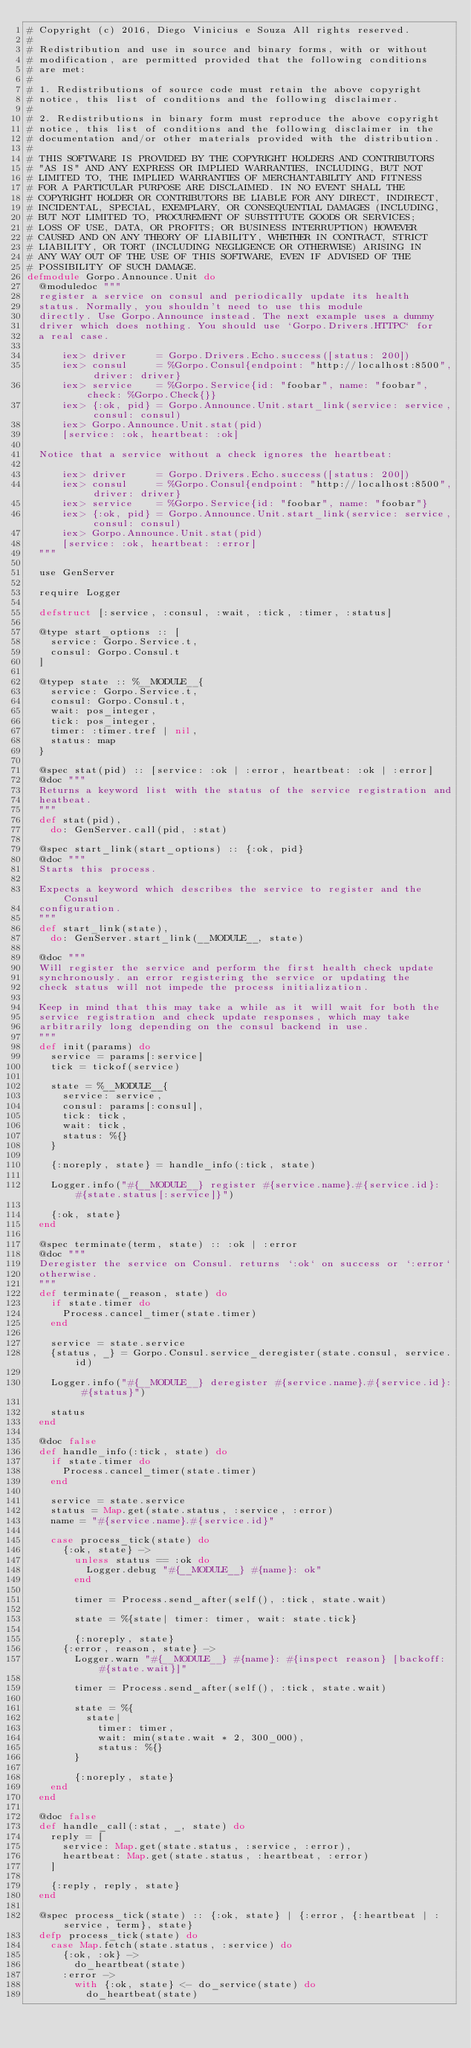<code> <loc_0><loc_0><loc_500><loc_500><_Elixir_># Copyright (c) 2016, Diego Vinicius e Souza All rights reserved.
#
# Redistribution and use in source and binary forms, with or without
# modification, are permitted provided that the following conditions
# are met:
#
# 1. Redistributions of source code must retain the above copyright
# notice, this list of conditions and the following disclaimer.
#
# 2. Redistributions in binary form must reproduce the above copyright
# notice, this list of conditions and the following disclaimer in the
# documentation and/or other materials provided with the distribution.
#
# THIS SOFTWARE IS PROVIDED BY THE COPYRIGHT HOLDERS AND CONTRIBUTORS
# "AS IS" AND ANY EXPRESS OR IMPLIED WARRANTIES, INCLUDING, BUT NOT
# LIMITED TO, THE IMPLIED WARRANTIES OF MERCHANTABILITY AND FITNESS
# FOR A PARTICULAR PURPOSE ARE DISCLAIMED. IN NO EVENT SHALL THE
# COPYRIGHT HOLDER OR CONTRIBUTORS BE LIABLE FOR ANY DIRECT, INDIRECT,
# INCIDENTAL, SPECIAL, EXEMPLARY, OR CONSEQUENTIAL DAMAGES (INCLUDING,
# BUT NOT LIMITED TO, PROCUREMENT OF SUBSTITUTE GOODS OR SERVICES;
# LOSS OF USE, DATA, OR PROFITS; OR BUSINESS INTERRUPTION) HOWEVER
# CAUSED AND ON ANY THEORY OF LIABILITY, WHETHER IN CONTRACT, STRICT
# LIABILITY, OR TORT (INCLUDING NEGLIGENCE OR OTHERWISE) ARISING IN
# ANY WAY OUT OF THE USE OF THIS SOFTWARE, EVEN IF ADVISED OF THE
# POSSIBILITY OF SUCH DAMAGE.
defmodule Gorpo.Announce.Unit do
  @moduledoc """
  register a service on consul and periodically update its health
  status. Normally, you shouldn't need to use this module
  directly. Use Gorpo.Announce instead. The next example uses a dummy
  driver which does nothing. You should use `Gorpo.Drivers.HTTPC` for
  a real case.

      iex> driver     = Gorpo.Drivers.Echo.success([status: 200])
      iex> consul     = %Gorpo.Consul{endpoint: "http://localhost:8500", driver: driver}
      iex> service    = %Gorpo.Service{id: "foobar", name: "foobar", check: %Gorpo.Check{}}
      iex> {:ok, pid} = Gorpo.Announce.Unit.start_link(service: service, consul: consul)
      iex> Gorpo.Announce.Unit.stat(pid)
      [service: :ok, heartbeat: :ok]

  Notice that a service without a check ignores the heartbeat:

      iex> driver     = Gorpo.Drivers.Echo.success([status: 200])
      iex> consul     = %Gorpo.Consul{endpoint: "http://localhost:8500", driver: driver}
      iex> service    = %Gorpo.Service{id: "foobar", name: "foobar"}
      iex> {:ok, pid} = Gorpo.Announce.Unit.start_link(service: service, consul: consul)
      iex> Gorpo.Announce.Unit.stat(pid)
      [service: :ok, heartbeat: :error]
  """

  use GenServer

  require Logger

  defstruct [:service, :consul, :wait, :tick, :timer, :status]

  @type start_options :: [
    service: Gorpo.Service.t,
    consul: Gorpo.Consul.t
  ]

  @typep state :: %__MODULE__{
    service: Gorpo.Service.t,
    consul: Gorpo.Consul.t,
    wait: pos_integer,
    tick: pos_integer,
    timer: :timer.tref | nil,
    status: map
  }

  @spec stat(pid) :: [service: :ok | :error, heartbeat: :ok | :error]
  @doc """
  Returns a keyword list with the status of the service registration and
  heatbeat.
  """
  def stat(pid),
    do: GenServer.call(pid, :stat)

  @spec start_link(start_options) :: {:ok, pid}
  @doc """
  Starts this process.

  Expects a keyword which describes the service to register and the Consul
  configuration.
  """
  def start_link(state),
    do: GenServer.start_link(__MODULE__, state)

  @doc """
  Will register the service and perform the first health check update
  synchronously. an error registering the service or updating the
  check status will not impede the process initialization.

  Keep in mind that this may take a while as it will wait for both the
  service registration and check update responses, which may take
  arbitrarily long depending on the consul backend in use.
  """
  def init(params) do
    service = params[:service]
    tick = tickof(service)

    state = %__MODULE__{
      service: service,
      consul: params[:consul],
      tick: tick,
      wait: tick,
      status: %{}
    }

    {:noreply, state} = handle_info(:tick, state)

    Logger.info("#{__MODULE__} register #{service.name}.#{service.id}: #{state.status[:service]}")

    {:ok, state}
  end

  @spec terminate(term, state) :: :ok | :error
  @doc """
  Deregister the service on Consul. returns `:ok` on success or `:error`
  otherwise.
  """
  def terminate(_reason, state) do
    if state.timer do
      Process.cancel_timer(state.timer)
    end

    service = state.service
    {status, _} = Gorpo.Consul.service_deregister(state.consul, service.id)

    Logger.info("#{__MODULE__} deregister #{service.name}.#{service.id}: #{status}")

    status
  end

  @doc false
  def handle_info(:tick, state) do
    if state.timer do
      Process.cancel_timer(state.timer)
    end

    service = state.service
    status = Map.get(state.status, :service, :error)
    name = "#{service.name}.#{service.id}"

    case process_tick(state) do
      {:ok, state} ->
        unless status == :ok do
          Logger.debug "#{__MODULE__} #{name}: ok"
        end

        timer = Process.send_after(self(), :tick, state.wait)

        state = %{state| timer: timer, wait: state.tick}

        {:noreply, state}
      {:error, reason, state} ->
        Logger.warn "#{__MODULE__} #{name}: #{inspect reason} [backoff: #{state.wait}]"

        timer = Process.send_after(self(), :tick, state.wait)

        state = %{
          state|
            timer: timer,
            wait: min(state.wait * 2, 300_000),
            status: %{}
        }

        {:noreply, state}
    end
  end

  @doc false
  def handle_call(:stat, _, state) do
    reply = [
      service: Map.get(state.status, :service, :error),
      heartbeat: Map.get(state.status, :heartbeat, :error)
    ]

    {:reply, reply, state}
  end

  @spec process_tick(state) :: {:ok, state} | {:error, {:heartbeat | :service, term}, state}
  defp process_tick(state) do
    case Map.fetch(state.status, :service) do
      {:ok, :ok} ->
        do_heartbeat(state)
      :error ->
        with {:ok, state} <- do_service(state) do
          do_heartbeat(state)</code> 